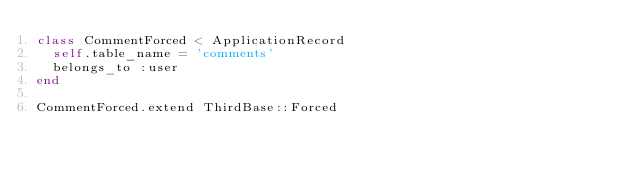<code> <loc_0><loc_0><loc_500><loc_500><_Ruby_>class CommentForced < ApplicationRecord
  self.table_name = 'comments'
  belongs_to :user
end

CommentForced.extend ThirdBase::Forced
</code> 